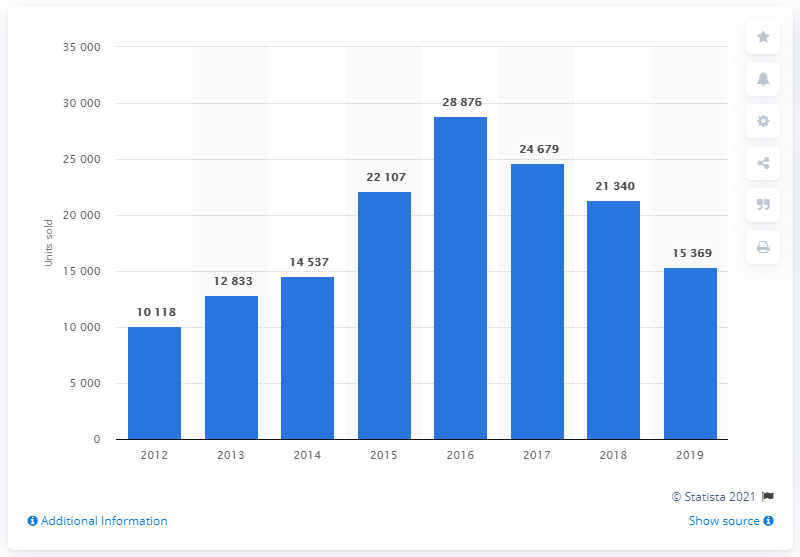Give some essential details in this illustration. In 2016, a total of 28,876 Skoda cars were sold in Turkey, which was the highest number of Skoda cars sold in that year. In 2019, Skoda sold a total of 15,369 cars in Turkey. 